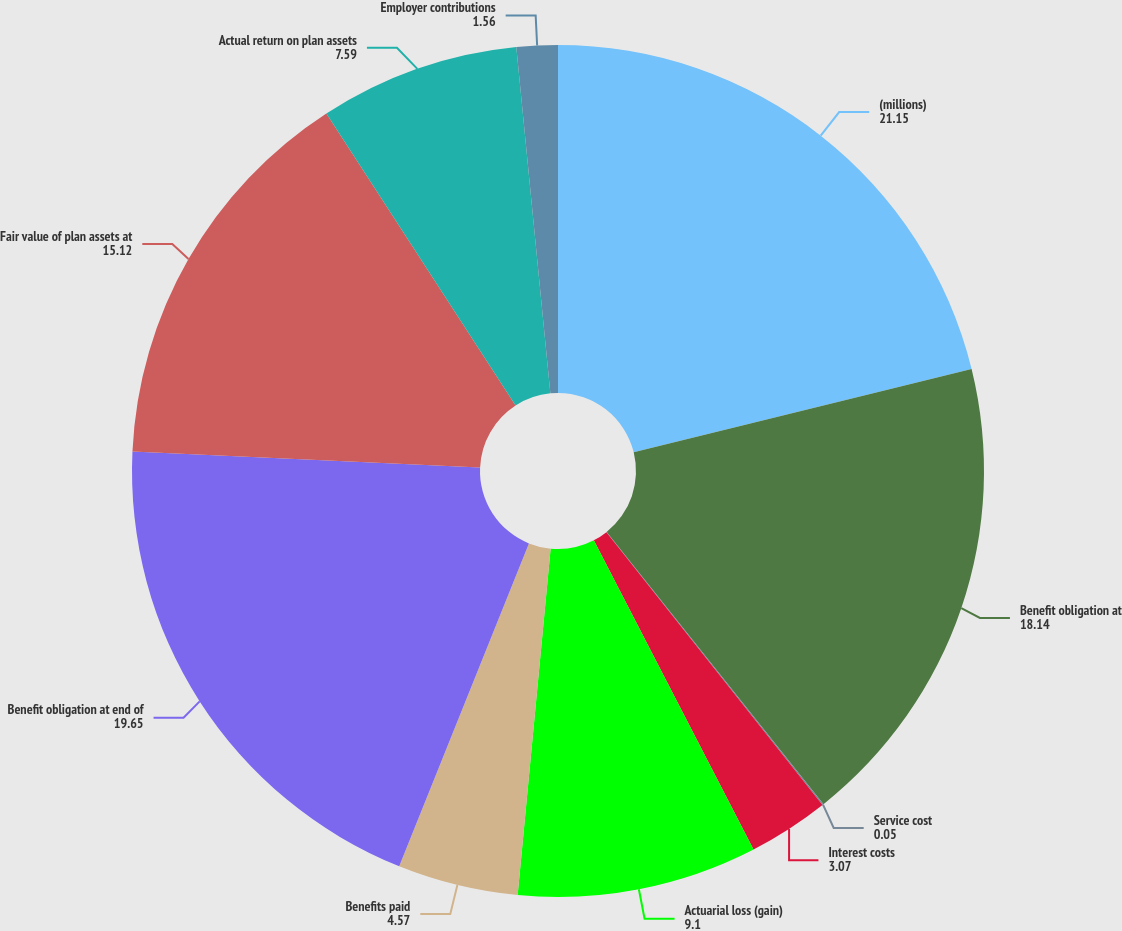Convert chart to OTSL. <chart><loc_0><loc_0><loc_500><loc_500><pie_chart><fcel>(millions)<fcel>Benefit obligation at<fcel>Service cost<fcel>Interest costs<fcel>Actuarial loss (gain)<fcel>Benefits paid<fcel>Benefit obligation at end of<fcel>Fair value of plan assets at<fcel>Actual return on plan assets<fcel>Employer contributions<nl><fcel>21.15%<fcel>18.14%<fcel>0.05%<fcel>3.07%<fcel>9.1%<fcel>4.57%<fcel>19.65%<fcel>15.12%<fcel>7.59%<fcel>1.56%<nl></chart> 